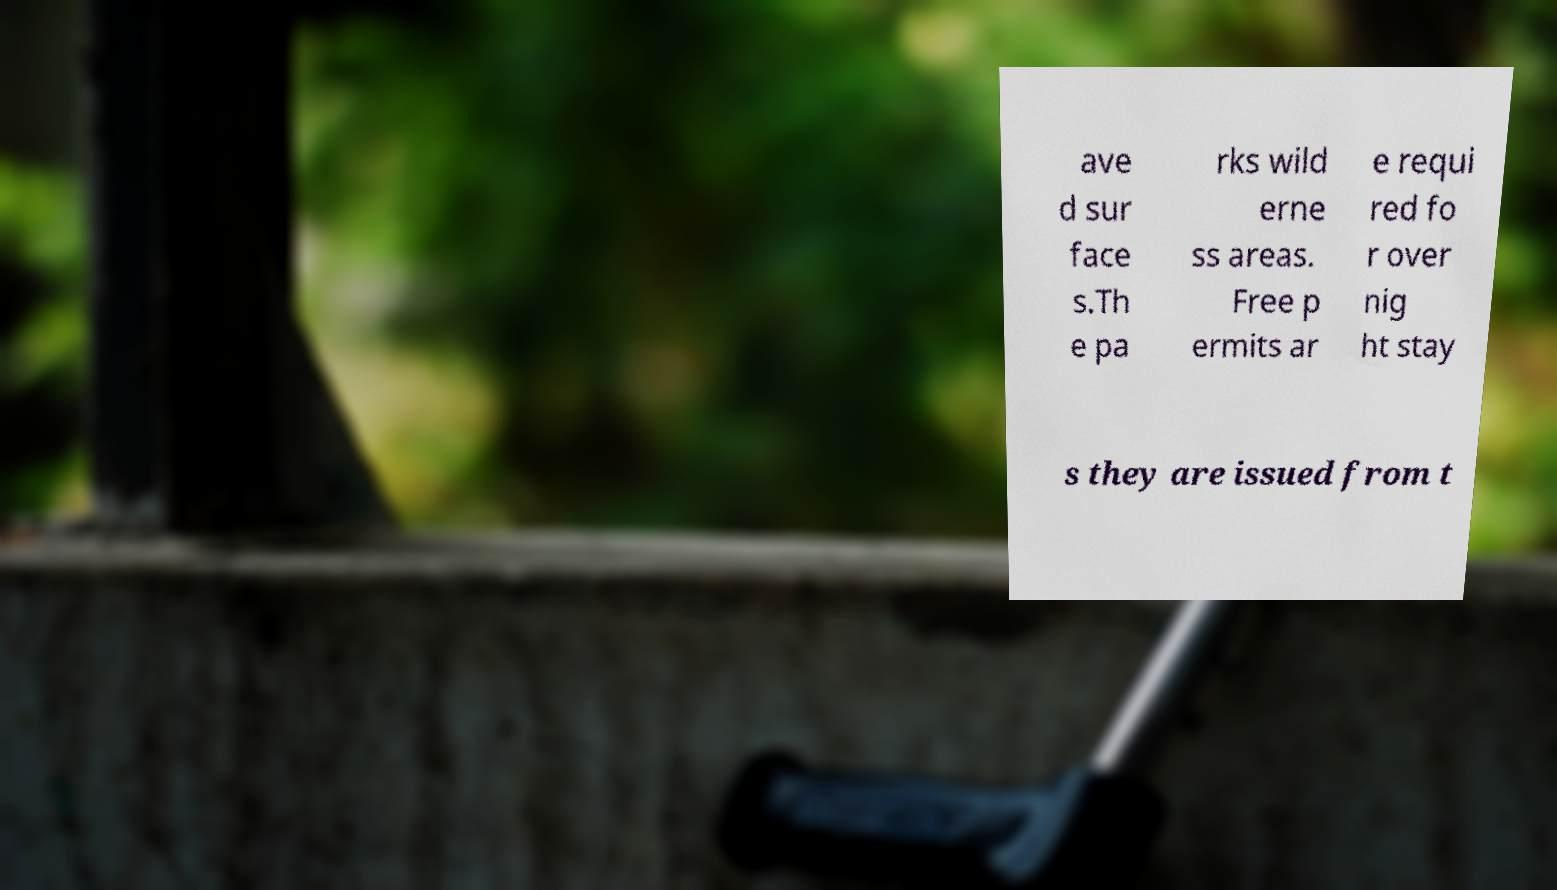Can you read and provide the text displayed in the image?This photo seems to have some interesting text. Can you extract and type it out for me? ave d sur face s.Th e pa rks wild erne ss areas. Free p ermits ar e requi red fo r over nig ht stay s they are issued from t 